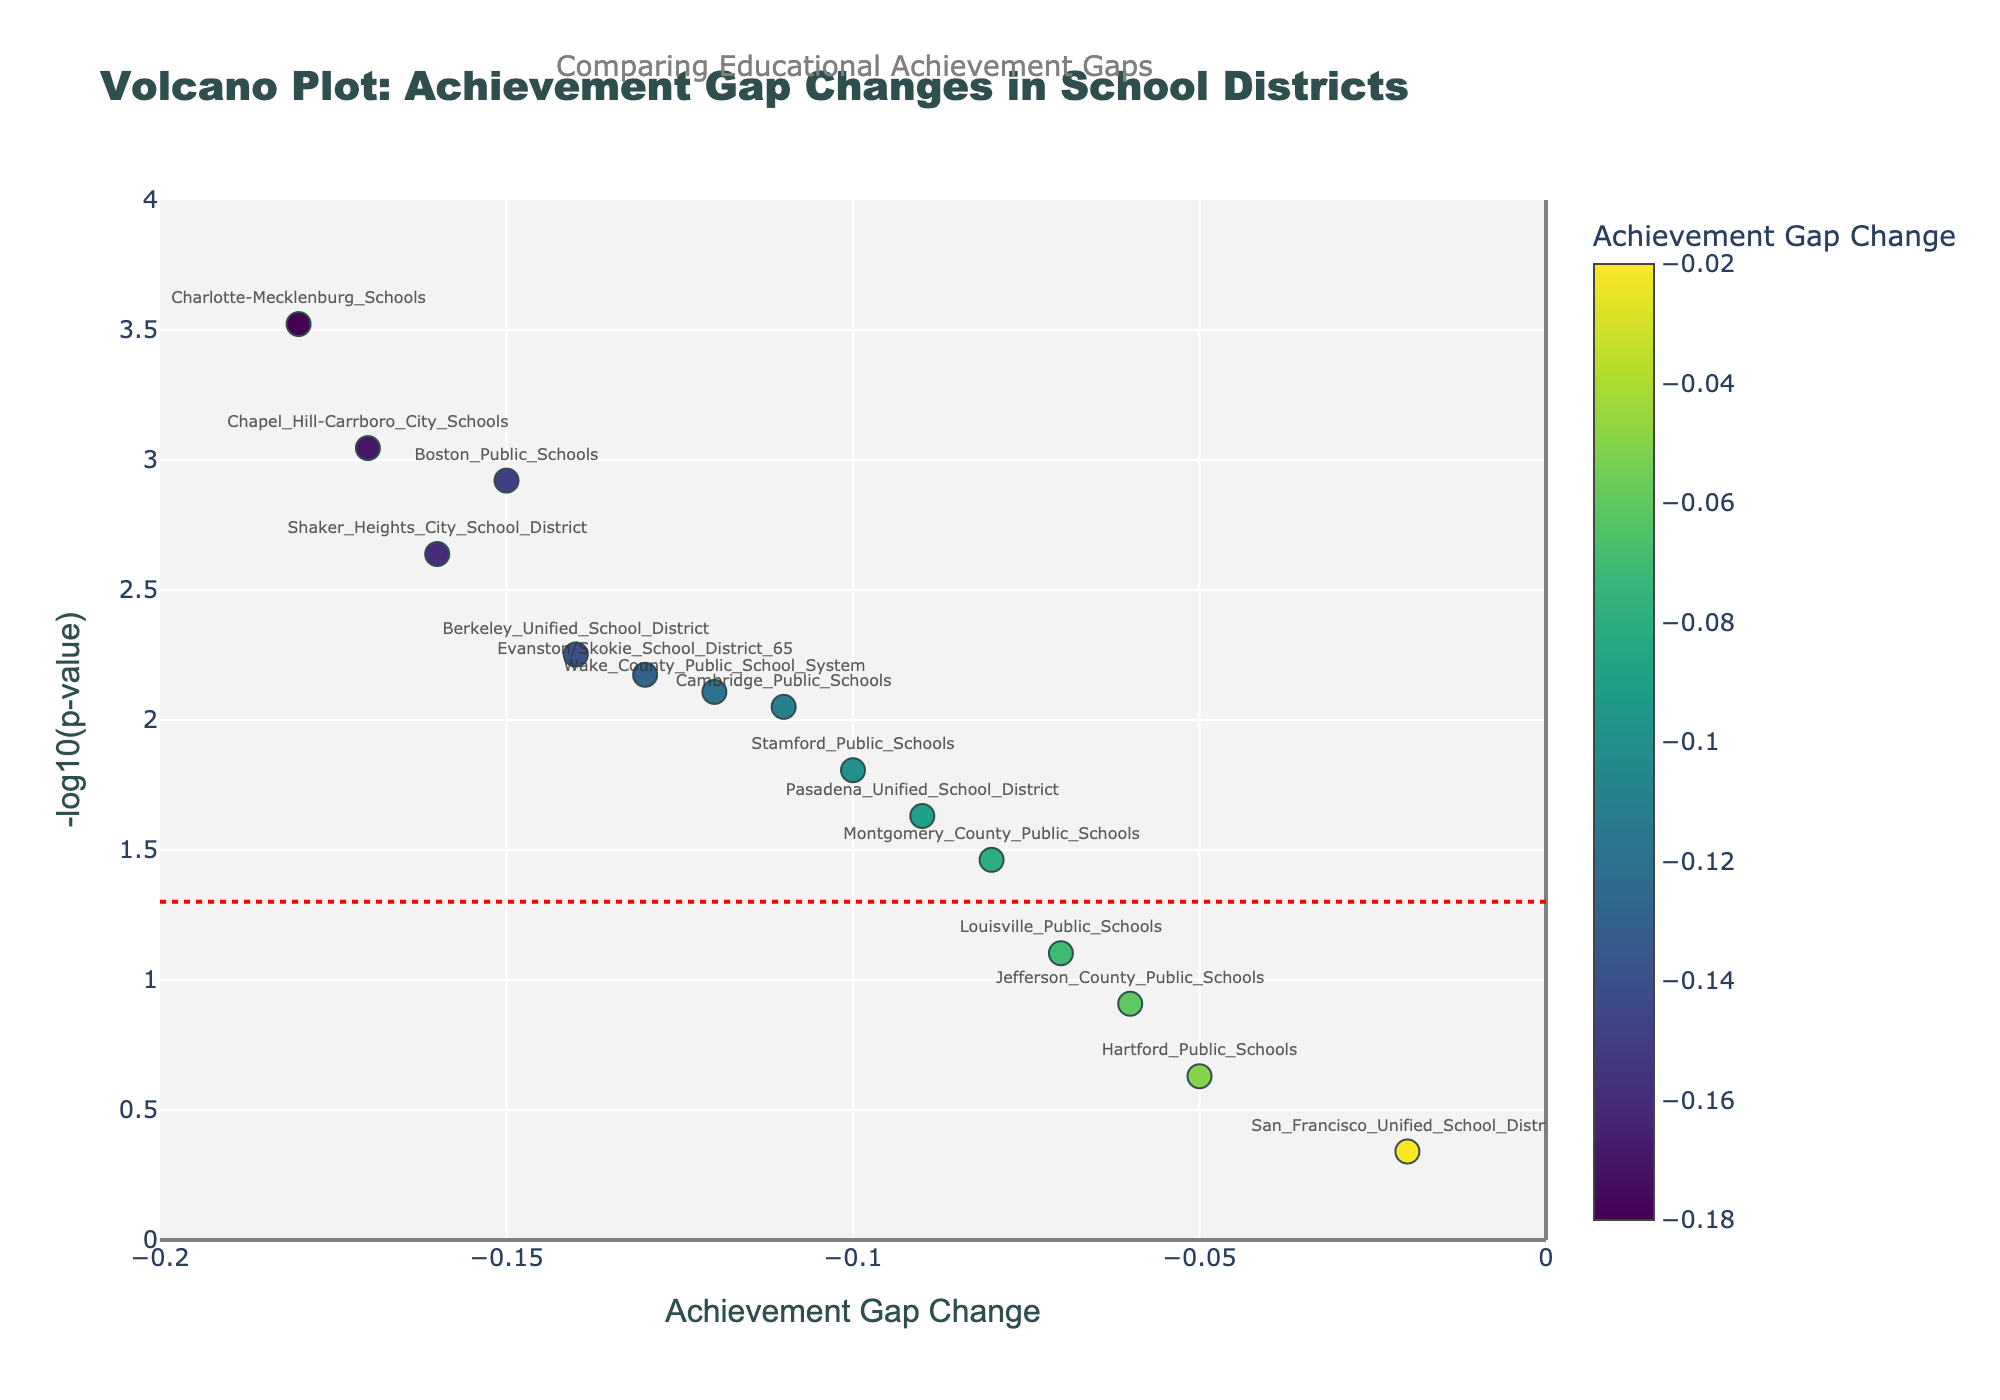Which school district has the smallest p-value? To find the smallest p-value, look for the highest point on the y-axis (-log10(p-value)) in the figure. The highest point corresponds to the lowest p-value.
Answer: Charlotte-Mecklenburg Schools What does the x-axis represent? The x-axis represents the Achievement Gap Change, indicating how the gap has widened or narrowed over time.
Answer: Achievement Gap Change Which school district shows the most significant decrease in the achievement gap? To identify the most significant decrease, look for a point that is furthest to the left on the x-axis and has a high -log10(p-value) value.
Answer: Charlotte-Mecklenburg Schools How many school districts have an Achievement Gap Change smaller than -0.10? Count the number of data points where the x-coordinate (Achievement Gap Change) is less than -0.10.
Answer: Nine What is the significance threshold used in the figure? The significance threshold is indicated by the red dashed line. Check the y-axis value where this line is drawn.
Answer: -log10(0.05) What is the Achievement Gap Change for Boston Public Schools? Find the data point labeled with Boston Public Schools and note its x-coordinate.
Answer: -0.15 Which school districts have a p-value greater than 0.05? Identify the data points below the significance threshold line (-log10(0.05)). These points correspond to school districts with a p-value greater than 0.05.
Answer: Jefferson County Public Schools, San Francisco Unified School District, Hartford Public Schools, Louisville Public Schools What is the average Achievement Gap Change for all school districts shown? Add up all the Achievement Gap Change values and divide by the number of school districts.
Answer: -0.1107 (rounded to four decimal places) Which school district has an Achievement Gap Change of -0.12? Locate the point on the x-axis where Achievement Gap Change is -0.12 and identify the corresponding school district.
Answer: Wake County Public School System Between Chapel Hill-Carrboro City Schools and Shaker Heights City School District, which one has a lower p-value? Compare the y-axis values (-log10(p-value)) for the points corresponding to Chapel Hill-Carrboro City Schools and Shaker Heights City School District. The higher y-axis value indicates the lower p-value.
Answer: Chapel Hill-Carrboro City Schools 